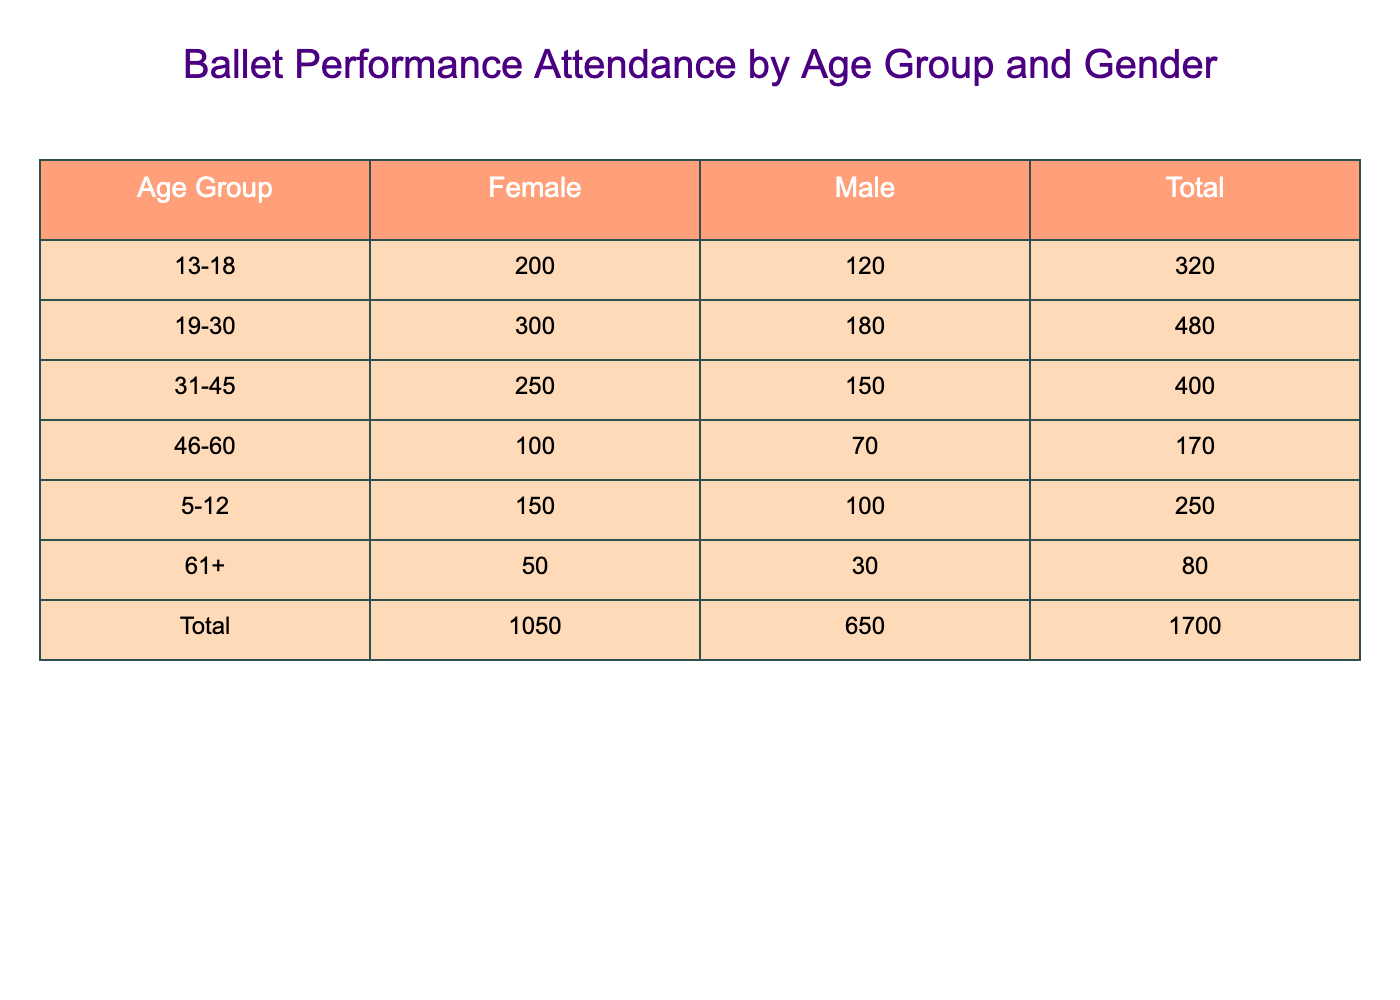What is the attendance count for the age group 19-30, female? From the table, looking under the "19-30" age group and in the "Female" column, the attendance count is 300.
Answer: 300 What is the total attendance for males in all age groups? To find the total attendance for males, we sum the attendance counts for all the male categories across the age groups: 100 + 120 + 180 + 150 + 70 + 30 = 750.
Answer: 750 Is the attendance for females aged 31-45 greater than the total attendance for males in the same age group? The attendance for females aged 31-45 is 250, and for males in the same age group, it is 150. Since 250 is greater than 150, the statement is true.
Answer: Yes What is the difference in attendance between the youngest age group (5-12) and the oldest age group (61+)? For the age group 5-12, the total attendance is 150 (female) + 100 (male) = 250. For the age group 61+, the total attendance is 50 (female) + 30 (male) = 80. The difference is 250 - 80 = 170.
Answer: 170 Which age group has the highest attendance for females? Checking the attendance counts for females in each age group, we find: 150 (5-12), 200 (13-18), 300 (19-30), 250 (31-45), 100 (46-60), and 50 (61+). The highest attendance is 300 in the 19-30 age group.
Answer: 19-30 What is the average attendance for males across all age groups? To find the average, we first sum the attendance for males: 100 + 120 + 180 + 150 + 70 + 30 = 750. There are 6 age groups, so we calculate the average as 750 / 6 = 125.
Answer: 125 Is there a higher attendance for ages 31-45 compared to ages 46-60 for males? The attendance for males in ages 31-45 is 150, while for ages 46-60 it is 70. Since 150 is higher than 70, the answer is yes.
Answer: Yes What is the total attendance for females aged 13-18 and 19-30 combined? We find the attendance counts: for ages 13-18 it is 200 and for ages 19-30 it is 300. Adding these gives 200 + 300 = 500.
Answer: 500 Which gender shows higher attendance in the age group 31-45? In the age group 31-45, the attendance is 250 for females and 150 for males. Since 250 is greater than 150, females show higher attendance.
Answer: Females 